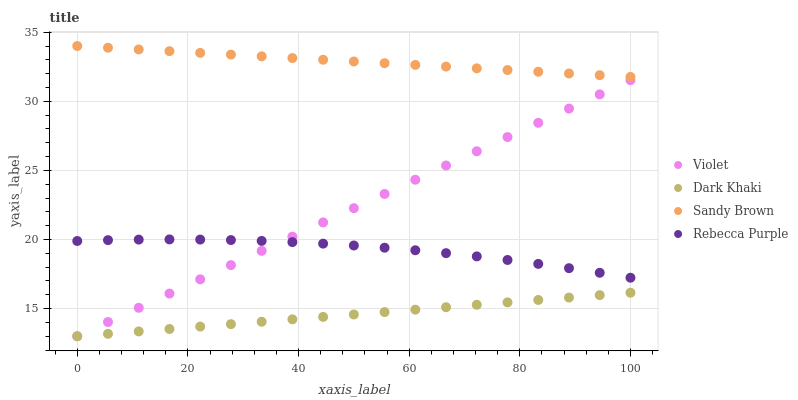Does Dark Khaki have the minimum area under the curve?
Answer yes or no. Yes. Does Sandy Brown have the maximum area under the curve?
Answer yes or no. Yes. Does Rebecca Purple have the minimum area under the curve?
Answer yes or no. No. Does Rebecca Purple have the maximum area under the curve?
Answer yes or no. No. Is Dark Khaki the smoothest?
Answer yes or no. Yes. Is Rebecca Purple the roughest?
Answer yes or no. Yes. Is Sandy Brown the smoothest?
Answer yes or no. No. Is Sandy Brown the roughest?
Answer yes or no. No. Does Dark Khaki have the lowest value?
Answer yes or no. Yes. Does Rebecca Purple have the lowest value?
Answer yes or no. No. Does Sandy Brown have the highest value?
Answer yes or no. Yes. Does Rebecca Purple have the highest value?
Answer yes or no. No. Is Dark Khaki less than Sandy Brown?
Answer yes or no. Yes. Is Rebecca Purple greater than Dark Khaki?
Answer yes or no. Yes. Does Violet intersect Rebecca Purple?
Answer yes or no. Yes. Is Violet less than Rebecca Purple?
Answer yes or no. No. Is Violet greater than Rebecca Purple?
Answer yes or no. No. Does Dark Khaki intersect Sandy Brown?
Answer yes or no. No. 